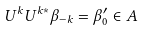<formula> <loc_0><loc_0><loc_500><loc_500>U ^ { k } U ^ { k * } \beta _ { - k } = \beta ^ { \prime } _ { 0 } \in A</formula> 